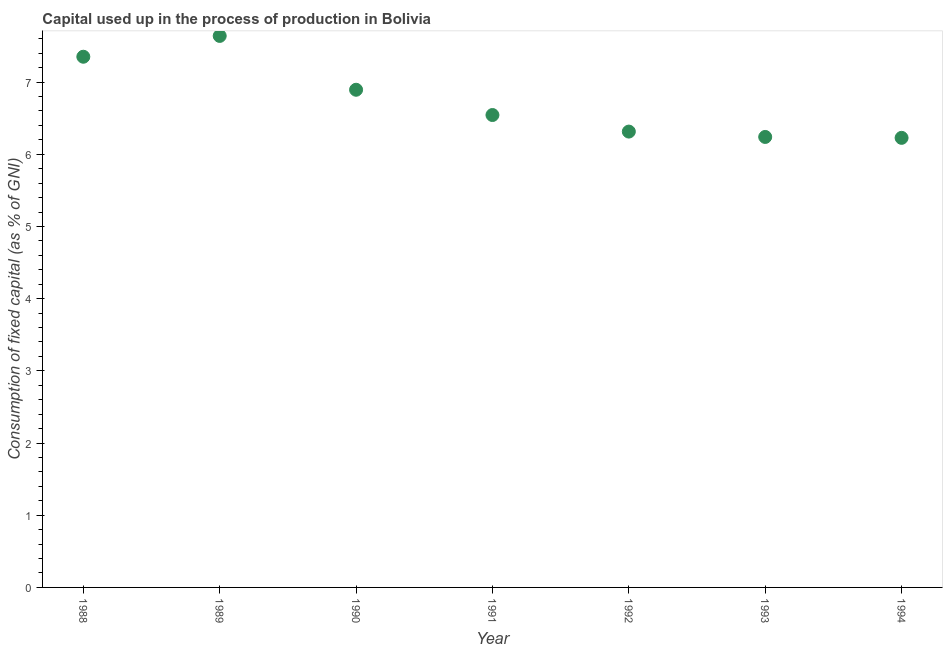What is the consumption of fixed capital in 1989?
Keep it short and to the point. 7.64. Across all years, what is the maximum consumption of fixed capital?
Offer a very short reply. 7.64. Across all years, what is the minimum consumption of fixed capital?
Provide a succinct answer. 6.23. In which year was the consumption of fixed capital minimum?
Offer a very short reply. 1994. What is the sum of the consumption of fixed capital?
Your response must be concise. 47.21. What is the difference between the consumption of fixed capital in 1989 and 1994?
Provide a succinct answer. 1.41. What is the average consumption of fixed capital per year?
Offer a very short reply. 6.74. What is the median consumption of fixed capital?
Provide a short and direct response. 6.54. In how many years, is the consumption of fixed capital greater than 7 %?
Your answer should be very brief. 2. What is the ratio of the consumption of fixed capital in 1989 to that in 1992?
Ensure brevity in your answer.  1.21. Is the consumption of fixed capital in 1988 less than that in 1990?
Your answer should be very brief. No. What is the difference between the highest and the second highest consumption of fixed capital?
Give a very brief answer. 0.29. Is the sum of the consumption of fixed capital in 1991 and 1993 greater than the maximum consumption of fixed capital across all years?
Offer a very short reply. Yes. What is the difference between the highest and the lowest consumption of fixed capital?
Offer a very short reply. 1.41. Does the consumption of fixed capital monotonically increase over the years?
Offer a very short reply. No. Are the values on the major ticks of Y-axis written in scientific E-notation?
Provide a short and direct response. No. Does the graph contain any zero values?
Your answer should be compact. No. What is the title of the graph?
Give a very brief answer. Capital used up in the process of production in Bolivia. What is the label or title of the X-axis?
Keep it short and to the point. Year. What is the label or title of the Y-axis?
Ensure brevity in your answer.  Consumption of fixed capital (as % of GNI). What is the Consumption of fixed capital (as % of GNI) in 1988?
Give a very brief answer. 7.35. What is the Consumption of fixed capital (as % of GNI) in 1989?
Give a very brief answer. 7.64. What is the Consumption of fixed capital (as % of GNI) in 1990?
Offer a terse response. 6.89. What is the Consumption of fixed capital (as % of GNI) in 1991?
Ensure brevity in your answer.  6.54. What is the Consumption of fixed capital (as % of GNI) in 1992?
Your answer should be very brief. 6.31. What is the Consumption of fixed capital (as % of GNI) in 1993?
Your response must be concise. 6.24. What is the Consumption of fixed capital (as % of GNI) in 1994?
Your answer should be very brief. 6.23. What is the difference between the Consumption of fixed capital (as % of GNI) in 1988 and 1989?
Offer a terse response. -0.29. What is the difference between the Consumption of fixed capital (as % of GNI) in 1988 and 1990?
Your answer should be compact. 0.46. What is the difference between the Consumption of fixed capital (as % of GNI) in 1988 and 1991?
Offer a very short reply. 0.81. What is the difference between the Consumption of fixed capital (as % of GNI) in 1988 and 1992?
Keep it short and to the point. 1.04. What is the difference between the Consumption of fixed capital (as % of GNI) in 1988 and 1993?
Make the answer very short. 1.11. What is the difference between the Consumption of fixed capital (as % of GNI) in 1988 and 1994?
Your answer should be very brief. 1.12. What is the difference between the Consumption of fixed capital (as % of GNI) in 1989 and 1990?
Offer a terse response. 0.75. What is the difference between the Consumption of fixed capital (as % of GNI) in 1989 and 1991?
Your response must be concise. 1.1. What is the difference between the Consumption of fixed capital (as % of GNI) in 1989 and 1992?
Offer a terse response. 1.33. What is the difference between the Consumption of fixed capital (as % of GNI) in 1989 and 1993?
Your answer should be compact. 1.4. What is the difference between the Consumption of fixed capital (as % of GNI) in 1989 and 1994?
Give a very brief answer. 1.41. What is the difference between the Consumption of fixed capital (as % of GNI) in 1990 and 1991?
Ensure brevity in your answer.  0.35. What is the difference between the Consumption of fixed capital (as % of GNI) in 1990 and 1992?
Offer a very short reply. 0.58. What is the difference between the Consumption of fixed capital (as % of GNI) in 1990 and 1993?
Provide a short and direct response. 0.65. What is the difference between the Consumption of fixed capital (as % of GNI) in 1990 and 1994?
Offer a very short reply. 0.67. What is the difference between the Consumption of fixed capital (as % of GNI) in 1991 and 1992?
Offer a terse response. 0.23. What is the difference between the Consumption of fixed capital (as % of GNI) in 1991 and 1993?
Offer a very short reply. 0.3. What is the difference between the Consumption of fixed capital (as % of GNI) in 1991 and 1994?
Your answer should be very brief. 0.32. What is the difference between the Consumption of fixed capital (as % of GNI) in 1992 and 1993?
Your answer should be compact. 0.07. What is the difference between the Consumption of fixed capital (as % of GNI) in 1992 and 1994?
Your response must be concise. 0.09. What is the difference between the Consumption of fixed capital (as % of GNI) in 1993 and 1994?
Offer a very short reply. 0.01. What is the ratio of the Consumption of fixed capital (as % of GNI) in 1988 to that in 1990?
Offer a terse response. 1.07. What is the ratio of the Consumption of fixed capital (as % of GNI) in 1988 to that in 1991?
Make the answer very short. 1.12. What is the ratio of the Consumption of fixed capital (as % of GNI) in 1988 to that in 1992?
Provide a succinct answer. 1.16. What is the ratio of the Consumption of fixed capital (as % of GNI) in 1988 to that in 1993?
Your answer should be very brief. 1.18. What is the ratio of the Consumption of fixed capital (as % of GNI) in 1988 to that in 1994?
Your answer should be very brief. 1.18. What is the ratio of the Consumption of fixed capital (as % of GNI) in 1989 to that in 1990?
Provide a succinct answer. 1.11. What is the ratio of the Consumption of fixed capital (as % of GNI) in 1989 to that in 1991?
Your answer should be compact. 1.17. What is the ratio of the Consumption of fixed capital (as % of GNI) in 1989 to that in 1992?
Offer a very short reply. 1.21. What is the ratio of the Consumption of fixed capital (as % of GNI) in 1989 to that in 1993?
Offer a very short reply. 1.22. What is the ratio of the Consumption of fixed capital (as % of GNI) in 1989 to that in 1994?
Give a very brief answer. 1.23. What is the ratio of the Consumption of fixed capital (as % of GNI) in 1990 to that in 1991?
Offer a terse response. 1.05. What is the ratio of the Consumption of fixed capital (as % of GNI) in 1990 to that in 1992?
Give a very brief answer. 1.09. What is the ratio of the Consumption of fixed capital (as % of GNI) in 1990 to that in 1993?
Offer a very short reply. 1.1. What is the ratio of the Consumption of fixed capital (as % of GNI) in 1990 to that in 1994?
Ensure brevity in your answer.  1.11. What is the ratio of the Consumption of fixed capital (as % of GNI) in 1991 to that in 1992?
Provide a succinct answer. 1.04. What is the ratio of the Consumption of fixed capital (as % of GNI) in 1991 to that in 1993?
Provide a short and direct response. 1.05. What is the ratio of the Consumption of fixed capital (as % of GNI) in 1991 to that in 1994?
Keep it short and to the point. 1.05. What is the ratio of the Consumption of fixed capital (as % of GNI) in 1992 to that in 1994?
Provide a succinct answer. 1.01. What is the ratio of the Consumption of fixed capital (as % of GNI) in 1993 to that in 1994?
Offer a terse response. 1. 